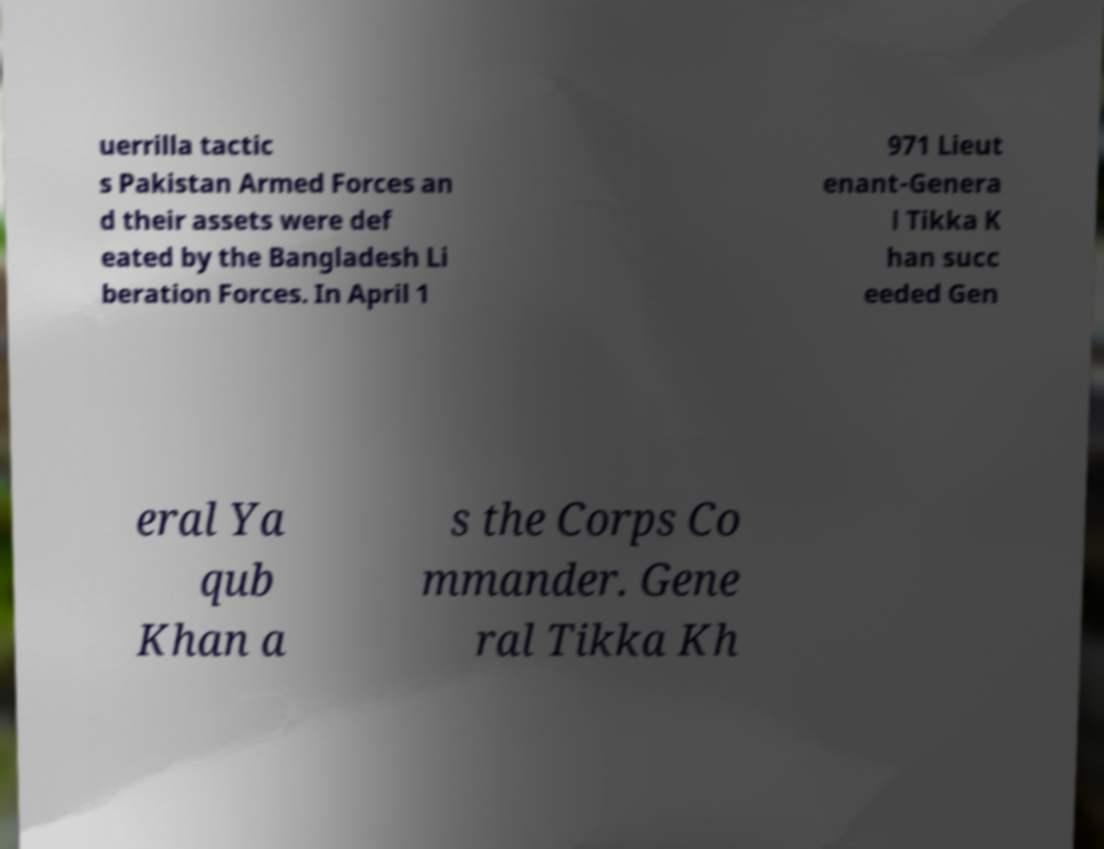Please identify and transcribe the text found in this image. uerrilla tactic s Pakistan Armed Forces an d their assets were def eated by the Bangladesh Li beration Forces. In April 1 971 Lieut enant-Genera l Tikka K han succ eeded Gen eral Ya qub Khan a s the Corps Co mmander. Gene ral Tikka Kh 